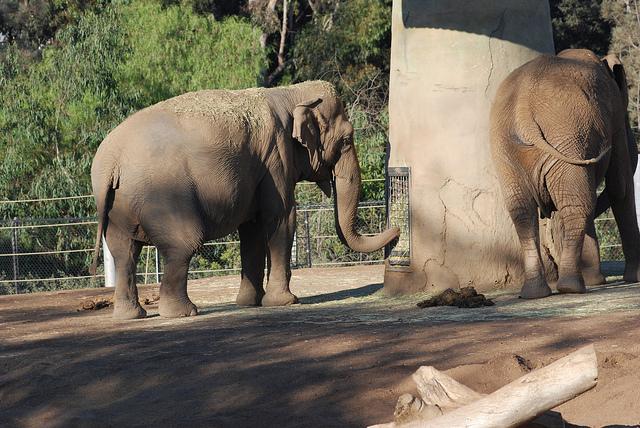Is the elephant trying to push the feeder over?
Keep it brief. No. Where is the log?
Concise answer only. Bottom right. Are the elephants in a zoo?
Be succinct. Yes. How many elephants are there?
Concise answer only. 2. How many elephants are in the photo?
Keep it brief. 2. Is this mother and child?
Quick response, please. Yes. What makes this picture odd is that the elephants are mixed with what?
Quick response, please. Concrete. What are the round black objects on the ground?
Keep it brief. Poop. How many tusks are on each elephant?
Answer briefly. 0. 